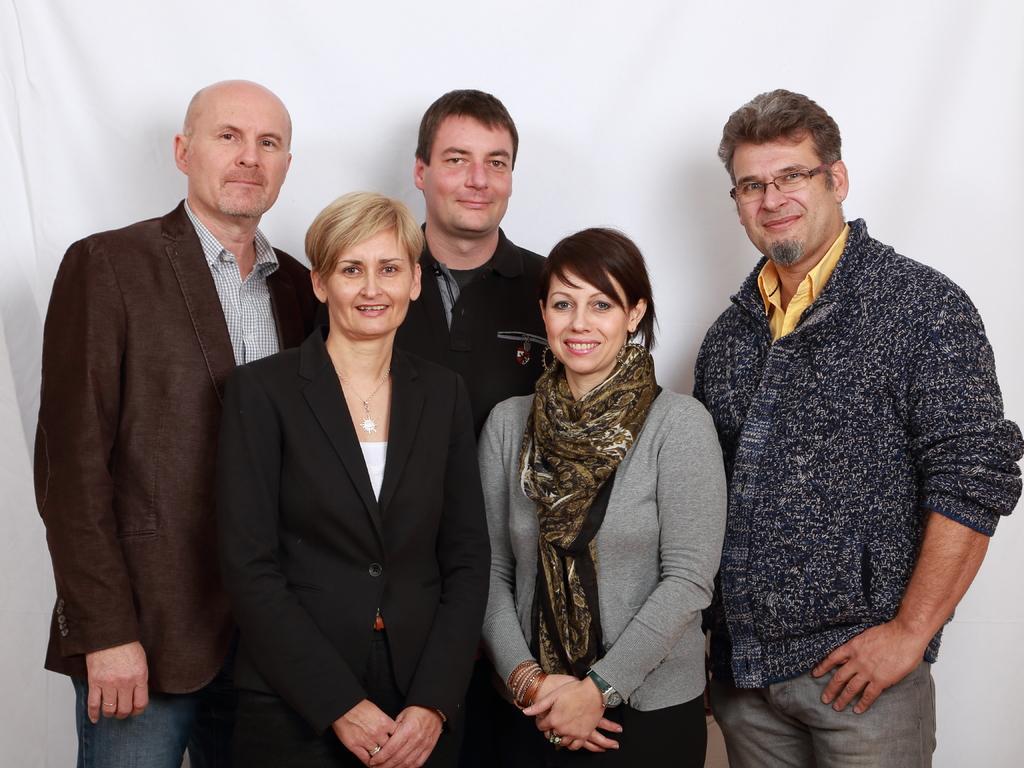Could you give a brief overview of what you see in this image? In this image there are three men and two women in the background there is white cloth. 